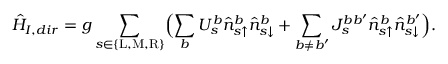<formula> <loc_0><loc_0><loc_500><loc_500>\hat { H } _ { I , d i r } = g \sum _ { s \in \{ L , M , R \} } \left ( \sum _ { b } U _ { s } ^ { b } \hat { n } _ { s \uparrow } ^ { b } \hat { n } _ { s \downarrow } ^ { b } + \sum _ { b \neq b ^ { \prime } } J _ { s } ^ { b b ^ { \prime } } \hat { n } _ { s \uparrow } ^ { b } \hat { n } _ { s \downarrow } ^ { b ^ { \prime } } \right ) .</formula> 